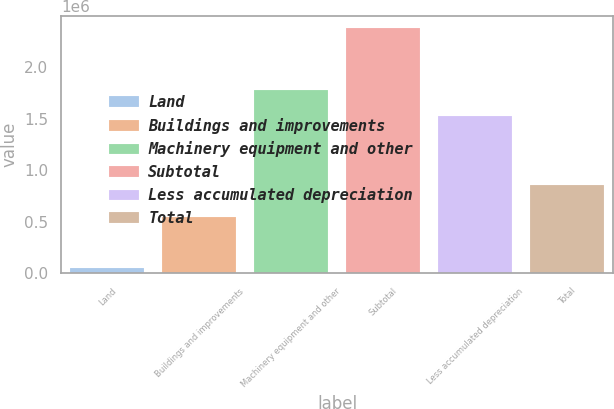Convert chart. <chart><loc_0><loc_0><loc_500><loc_500><bar_chart><fcel>Land<fcel>Buildings and improvements<fcel>Machinery equipment and other<fcel>Subtotal<fcel>Less accumulated depreciation<fcel>Total<nl><fcel>55567<fcel>546809<fcel>1.77203e+06<fcel>2.37441e+06<fcel>1.52014e+06<fcel>854269<nl></chart> 